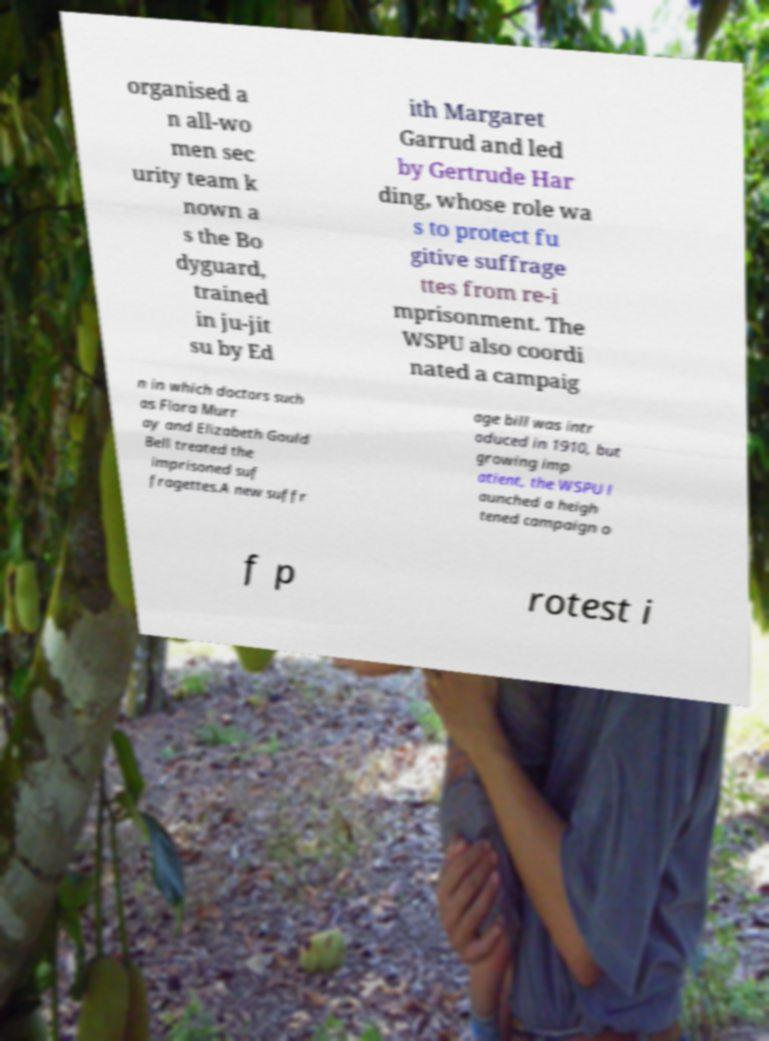Can you read and provide the text displayed in the image?This photo seems to have some interesting text. Can you extract and type it out for me? organised a n all-wo men sec urity team k nown a s the Bo dyguard, trained in ju-jit su by Ed ith Margaret Garrud and led by Gertrude Har ding, whose role wa s to protect fu gitive suffrage ttes from re-i mprisonment. The WSPU also coordi nated a campaig n in which doctors such as Flora Murr ay and Elizabeth Gould Bell treated the imprisoned suf fragettes.A new suffr age bill was intr oduced in 1910, but growing imp atient, the WSPU l aunched a heigh tened campaign o f p rotest i 